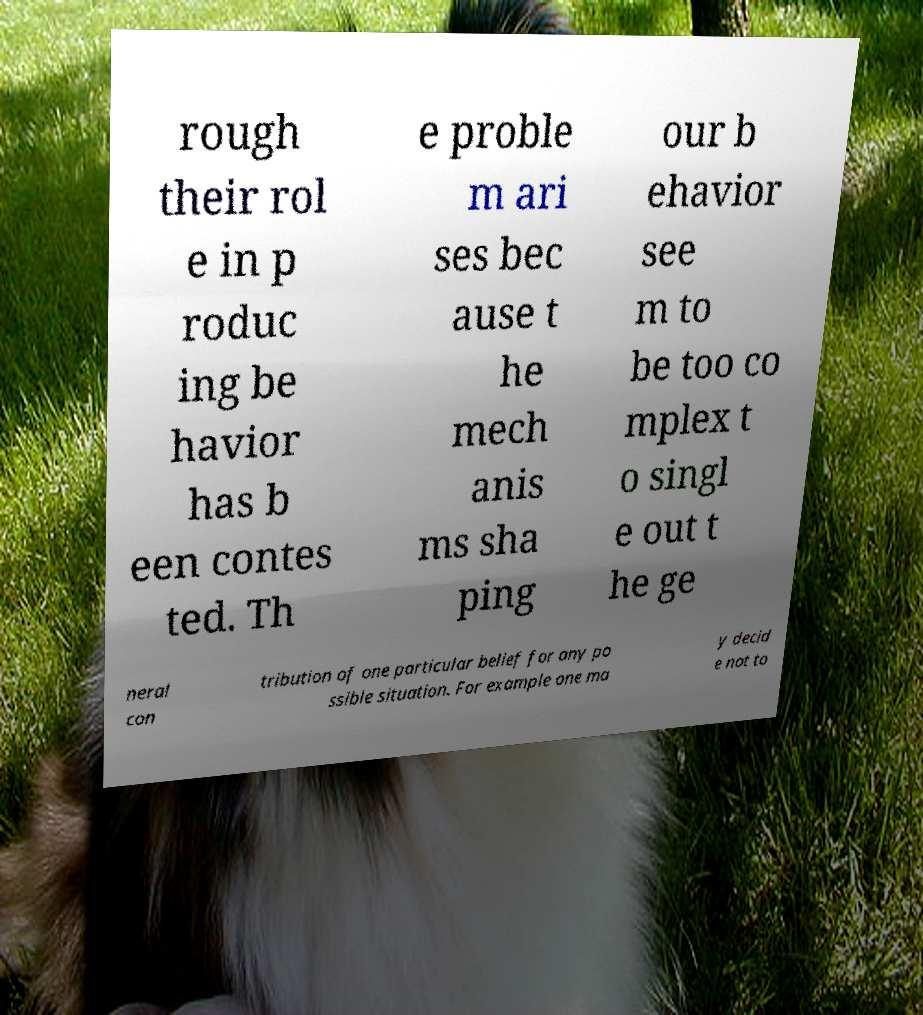Can you read and provide the text displayed in the image?This photo seems to have some interesting text. Can you extract and type it out for me? rough their rol e in p roduc ing be havior has b een contes ted. Th e proble m ari ses bec ause t he mech anis ms sha ping our b ehavior see m to be too co mplex t o singl e out t he ge neral con tribution of one particular belief for any po ssible situation. For example one ma y decid e not to 